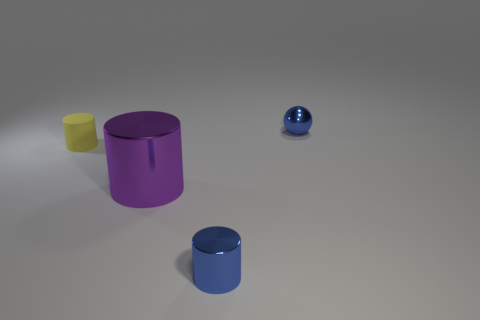How many objects are there in total, and can you describe their arrangements? There are three objects in total. Starting from the left, there is a small yellow cylinder, a medium-sized purple cylinder, and to the far right, a small blue sphere. They are arranged in a diagonal line across the image from left to right. Considering their positions, do these objects create any specific pattern or alignment? Given their placements, the objects create a descending line from the biggest to the smallest, possibly suggesting a perspective or size comparison. 